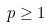<formula> <loc_0><loc_0><loc_500><loc_500>p \geq 1</formula> 